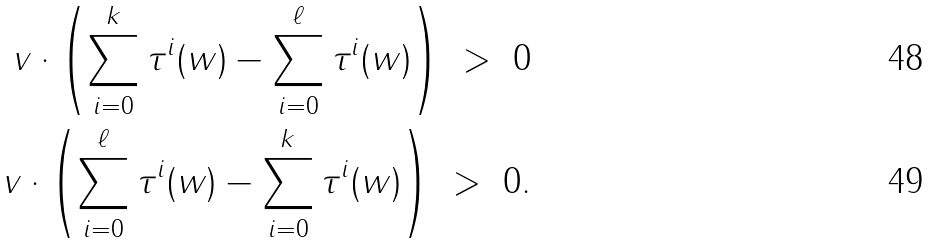Convert formula to latex. <formula><loc_0><loc_0><loc_500><loc_500>v \cdot \left ( \sum _ { i = 0 } ^ { k } \tau ^ { i } ( w ) - \sum _ { i = 0 } ^ { \ell } \tau ^ { i } ( w ) \right ) \ > \ 0 \\ v \cdot \left ( \sum _ { i = 0 } ^ { \ell } \tau ^ { i } ( w ) - \sum _ { i = 0 } ^ { k } \tau ^ { i } ( w ) \right ) \ > \ 0 .</formula> 